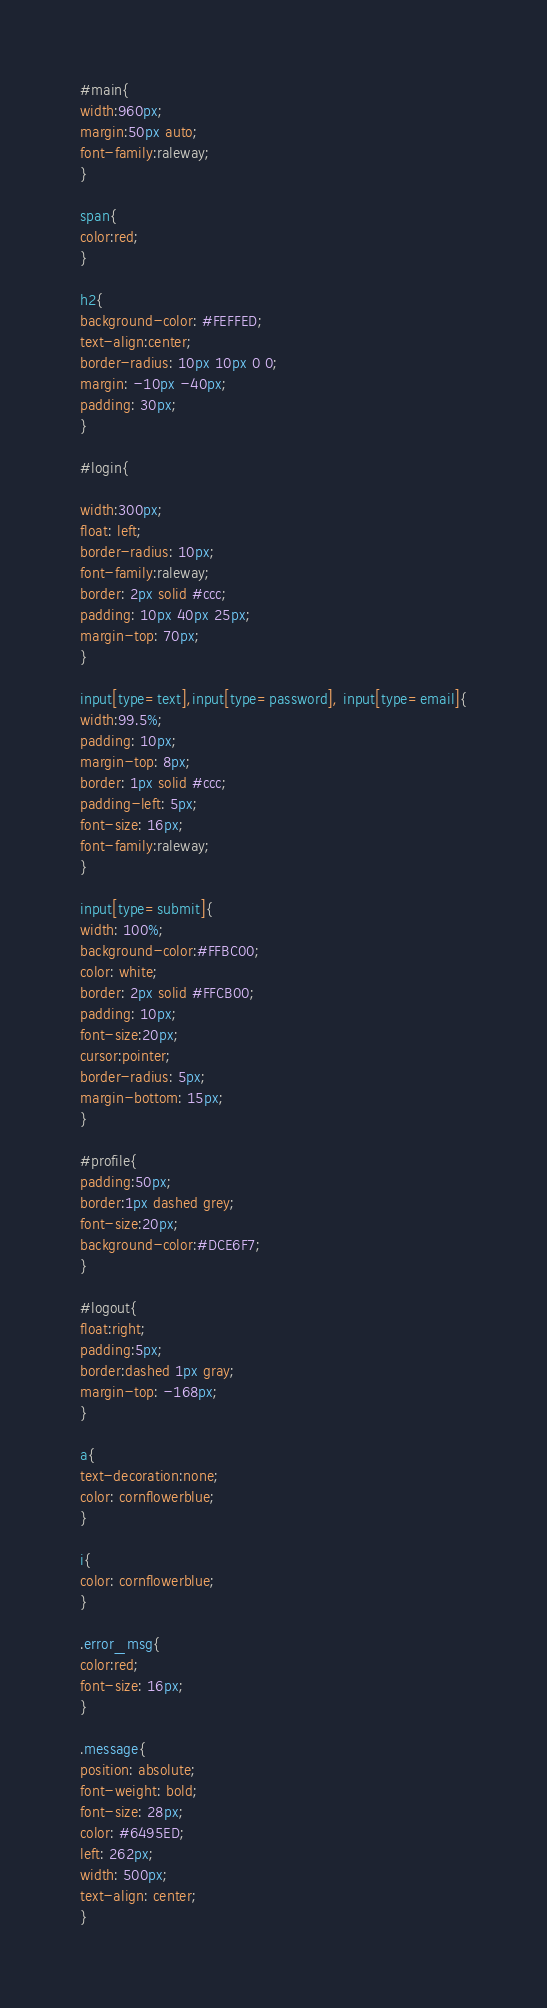<code> <loc_0><loc_0><loc_500><loc_500><_CSS_>#main{
width:960px;
margin:50px auto;
font-family:raleway;
}

span{
color:red;
}

h2{
background-color: #FEFFED;
text-align:center;
border-radius: 10px 10px 0 0;
margin: -10px -40px;
padding: 30px;
}

#login{

width:300px;
float: left;
border-radius: 10px;
font-family:raleway;
border: 2px solid #ccc;
padding: 10px 40px 25px;
margin-top: 70px;
}

input[type=text],input[type=password], input[type=email]{
width:99.5%;
padding: 10px;
margin-top: 8px;
border: 1px solid #ccc;
padding-left: 5px;
font-size: 16px;
font-family:raleway;
}

input[type=submit]{
width: 100%;
background-color:#FFBC00;
color: white;
border: 2px solid #FFCB00;
padding: 10px;
font-size:20px;
cursor:pointer;
border-radius: 5px;
margin-bottom: 15px;
}

#profile{
padding:50px;
border:1px dashed grey;
font-size:20px;
background-color:#DCE6F7;
}

#logout{
float:right;
padding:5px;
border:dashed 1px gray;
margin-top: -168px;
}

a{
text-decoration:none;
color: cornflowerblue;
}

i{
color: cornflowerblue;
}

.error_msg{
color:red;
font-size: 16px;
}

.message{
position: absolute;
font-weight: bold;
font-size: 28px;
color: #6495ED;
left: 262px;
width: 500px;
text-align: center;
}
</code> 